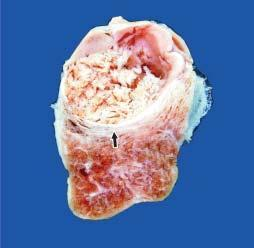s euroblastoma grey-white soft?
Answer the question using a single word or phrase. No 